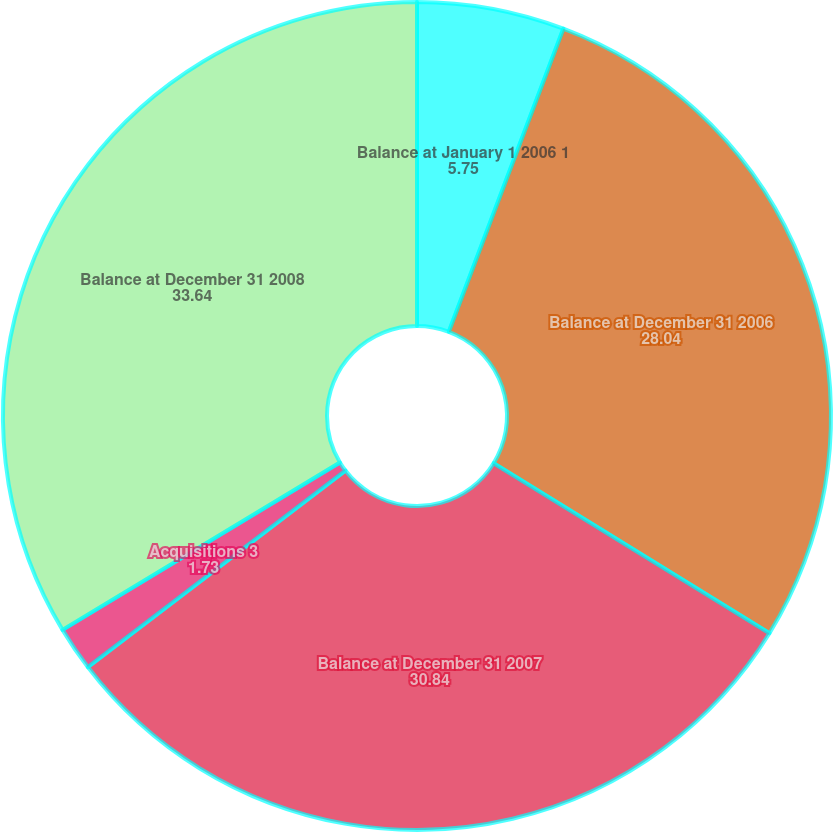<chart> <loc_0><loc_0><loc_500><loc_500><pie_chart><fcel>Balance at January 1 2006 1<fcel>Balance at December 31 2006<fcel>Balance at December 31 2007<fcel>Acquisitions 3<fcel>Balance at December 31 2008<nl><fcel>5.75%<fcel>28.04%<fcel>30.84%<fcel>1.73%<fcel>33.64%<nl></chart> 